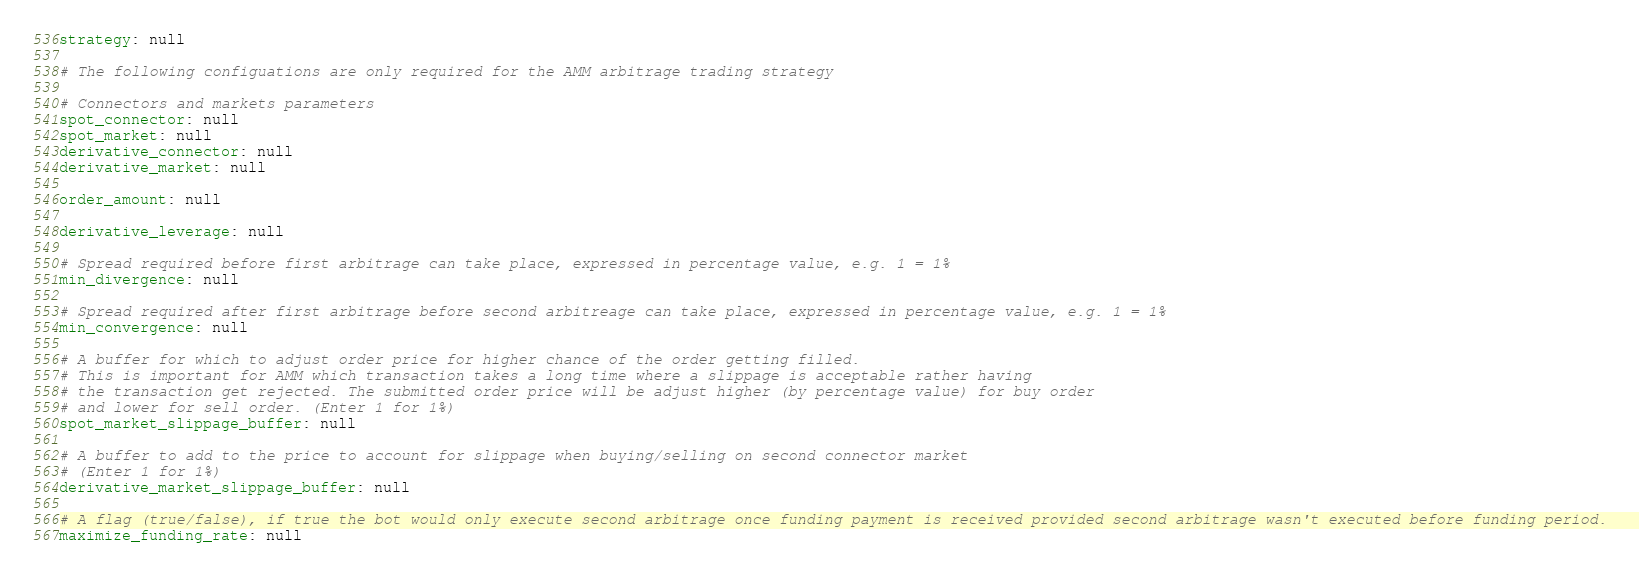<code> <loc_0><loc_0><loc_500><loc_500><_YAML_>strategy: null

# The following configuations are only required for the AMM arbitrage trading strategy

# Connectors and markets parameters
spot_connector: null
spot_market: null
derivative_connector: null
derivative_market: null

order_amount: null

derivative_leverage: null

# Spread required before first arbitrage can take place, expressed in percentage value, e.g. 1 = 1%
min_divergence: null

# Spread required after first arbitrage before second arbitreage can take place, expressed in percentage value, e.g. 1 = 1%
min_convergence: null

# A buffer for which to adjust order price for higher chance of the order getting filled.
# This is important for AMM which transaction takes a long time where a slippage is acceptable rather having
# the transaction get rejected. The submitted order price will be adjust higher (by percentage value) for buy order
# and lower for sell order. (Enter 1 for 1%)
spot_market_slippage_buffer: null

# A buffer to add to the price to account for slippage when buying/selling on second connector market
# (Enter 1 for 1%)
derivative_market_slippage_buffer: null

# A flag (true/false), if true the bot would only execute second arbitrage once funding payment is received provided second arbitrage wasn't executed before funding period.
maximize_funding_rate: null
</code> 